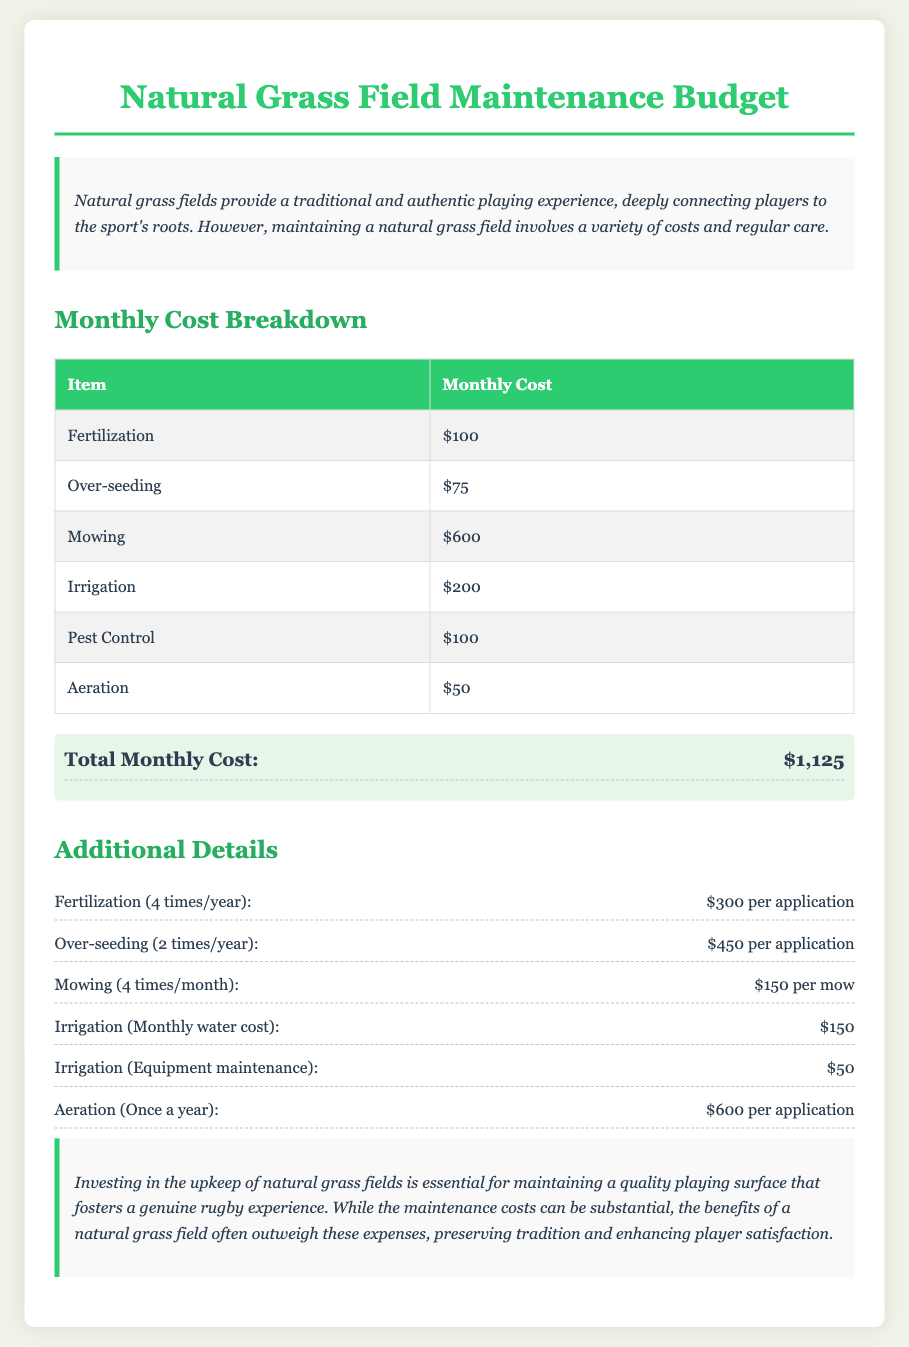What is the total monthly cost? The total monthly cost is calculated by adding up all individual maintenance costs listed in the document, which amounts to $1,125.
Answer: $1,125 How much does fertilization cost per application? The document states that fertilization costs $300 per application, which is done four times a year.
Answer: $300 How often is mowing performed? The document mentions that mowing is performed four times per month.
Answer: Four times per month What is the monthly cost of irrigation? The monthly cost for irrigation is specified in the document as $200.
Answer: $200 How much is the cost for over-seeding per application? The document lists the cost of over-seeding as $450 per application, done two times a year.
Answer: $450 What is the aeration cost per application? The document indicates that aeration costs $600 per application and is performed once a year.
Answer: $600 What type of grass field is discussed in the document? The document emphasizes the maintenance of natural grass fields and their benefits in rugby.
Answer: Natural grass What are the two main components contributing to fertilization costs? The document lists that fertilization occurs four times a year, costing $300 each time, totaling the maintenance effort.
Answer: $300 four times a year How does investing in maintenance benefit rugby experiences? The conclusion in the document states that investing in maintenance enhances player satisfaction and preserves tradition.
Answer: Enhances player satisfaction 